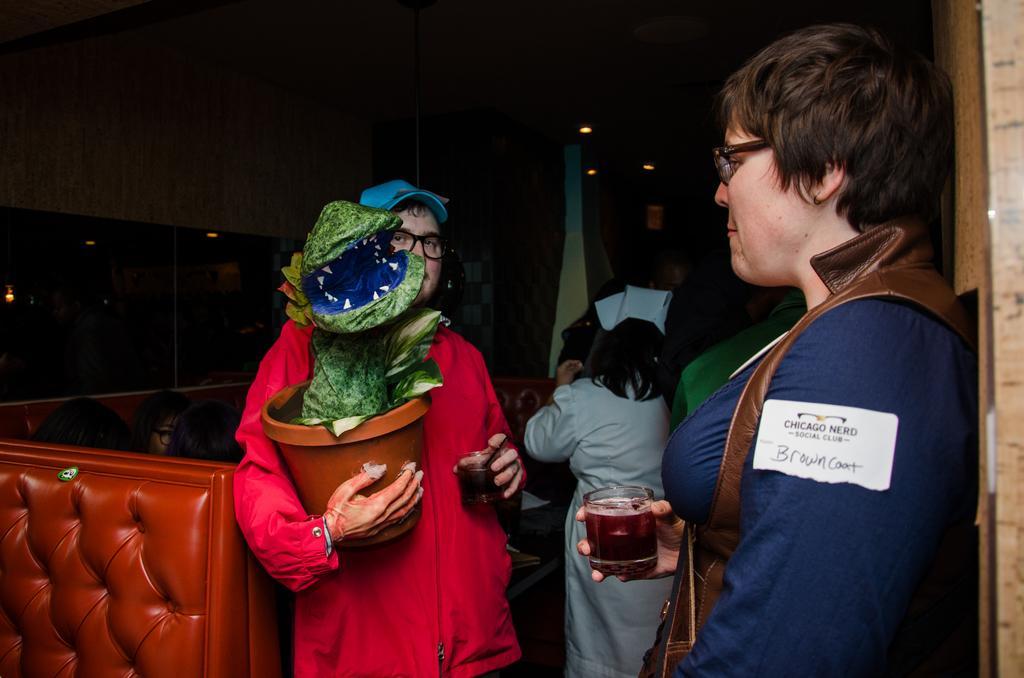Can you describe this image briefly? In this image I can see number of people where on the left side I can see few are sitting and rest all are standing. In the front I can see two of them are holding glasses and both of them are wearing specs, I can also see one of them is holding a pot and in the background I can see few lights. On the right side of this image I can see a white colour thing on her dress and on it I can see something is written. 